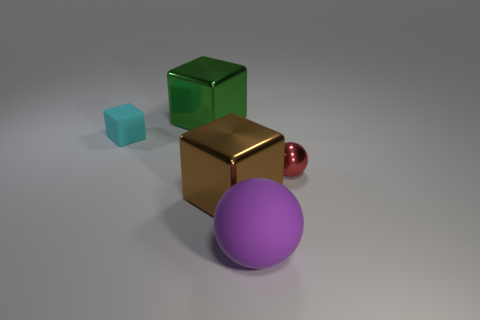The object that is both on the right side of the large brown shiny object and on the left side of the tiny sphere is made of what material? Considering the spatial description provided, the object of interest is the large purple sphere situated between the brown cube and the small red sphere. The sphere's smooth and matte finish suggests that it might be made of a hard plastic or potentially another non-metallic material rather than rubber. 